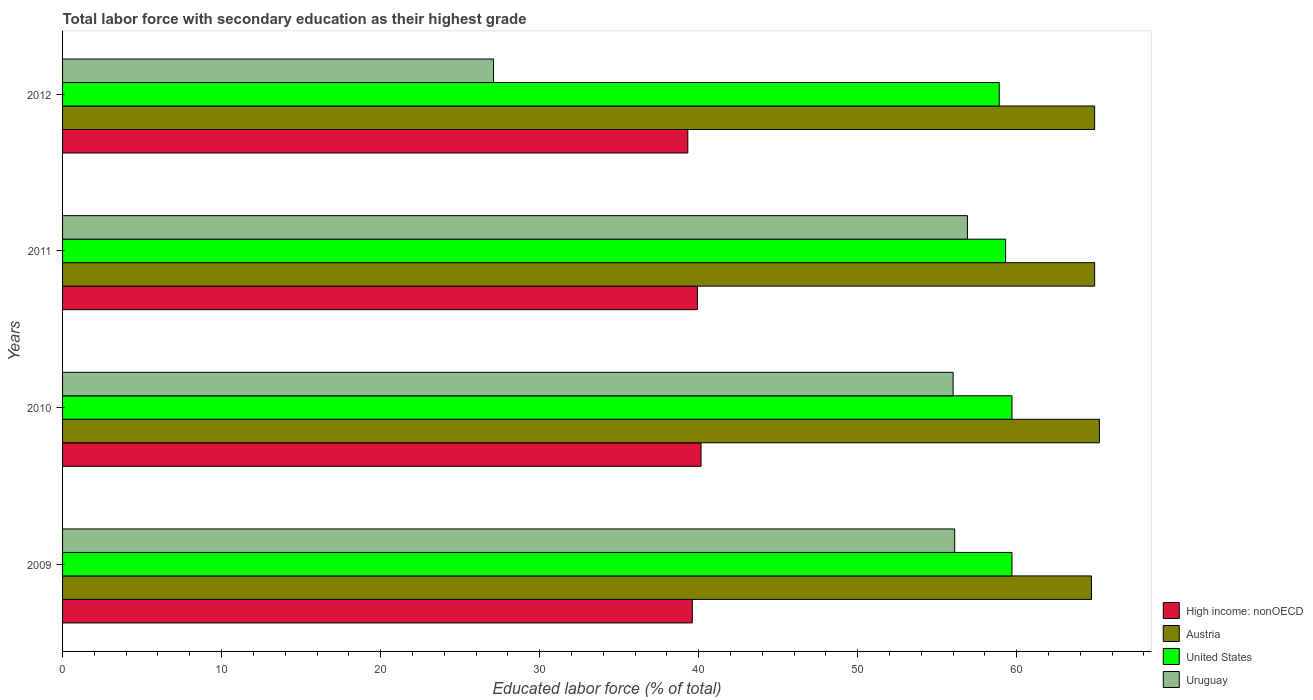How many bars are there on the 4th tick from the bottom?
Make the answer very short. 4. What is the percentage of total labor force with primary education in High income: nonOECD in 2010?
Give a very brief answer. 40.15. Across all years, what is the maximum percentage of total labor force with primary education in Uruguay?
Provide a short and direct response. 56.9. Across all years, what is the minimum percentage of total labor force with primary education in Uruguay?
Give a very brief answer. 27.1. In which year was the percentage of total labor force with primary education in High income: nonOECD minimum?
Offer a very short reply. 2012. What is the total percentage of total labor force with primary education in Austria in the graph?
Your answer should be compact. 259.7. What is the difference between the percentage of total labor force with primary education in Austria in 2011 and that in 2012?
Your response must be concise. 0. What is the difference between the percentage of total labor force with primary education in United States in 2009 and the percentage of total labor force with primary education in High income: nonOECD in 2011?
Make the answer very short. 19.78. What is the average percentage of total labor force with primary education in Uruguay per year?
Your response must be concise. 49.03. In the year 2011, what is the difference between the percentage of total labor force with primary education in Austria and percentage of total labor force with primary education in High income: nonOECD?
Provide a succinct answer. 24.98. What is the ratio of the percentage of total labor force with primary education in Austria in 2009 to that in 2012?
Provide a short and direct response. 1. Is the percentage of total labor force with primary education in Uruguay in 2010 less than that in 2012?
Make the answer very short. No. What is the difference between the highest and the lowest percentage of total labor force with primary education in High income: nonOECD?
Your answer should be very brief. 0.83. In how many years, is the percentage of total labor force with primary education in High income: nonOECD greater than the average percentage of total labor force with primary education in High income: nonOECD taken over all years?
Make the answer very short. 2. Is the sum of the percentage of total labor force with primary education in Uruguay in 2009 and 2011 greater than the maximum percentage of total labor force with primary education in High income: nonOECD across all years?
Your response must be concise. Yes. What does the 4th bar from the bottom in 2009 represents?
Provide a succinct answer. Uruguay. Is it the case that in every year, the sum of the percentage of total labor force with primary education in United States and percentage of total labor force with primary education in High income: nonOECD is greater than the percentage of total labor force with primary education in Austria?
Provide a short and direct response. Yes. Are all the bars in the graph horizontal?
Your answer should be compact. Yes. How many years are there in the graph?
Ensure brevity in your answer.  4. What is the difference between two consecutive major ticks on the X-axis?
Provide a succinct answer. 10. Are the values on the major ticks of X-axis written in scientific E-notation?
Ensure brevity in your answer.  No. Where does the legend appear in the graph?
Offer a very short reply. Bottom right. What is the title of the graph?
Offer a very short reply. Total labor force with secondary education as their highest grade. What is the label or title of the X-axis?
Provide a succinct answer. Educated labor force (% of total). What is the label or title of the Y-axis?
Provide a succinct answer. Years. What is the Educated labor force (% of total) of High income: nonOECD in 2009?
Your answer should be compact. 39.6. What is the Educated labor force (% of total) in Austria in 2009?
Keep it short and to the point. 64.7. What is the Educated labor force (% of total) of United States in 2009?
Your answer should be compact. 59.7. What is the Educated labor force (% of total) of Uruguay in 2009?
Offer a terse response. 56.1. What is the Educated labor force (% of total) of High income: nonOECD in 2010?
Offer a very short reply. 40.15. What is the Educated labor force (% of total) in Austria in 2010?
Offer a very short reply. 65.2. What is the Educated labor force (% of total) in United States in 2010?
Keep it short and to the point. 59.7. What is the Educated labor force (% of total) of High income: nonOECD in 2011?
Your response must be concise. 39.92. What is the Educated labor force (% of total) in Austria in 2011?
Offer a terse response. 64.9. What is the Educated labor force (% of total) of United States in 2011?
Offer a very short reply. 59.3. What is the Educated labor force (% of total) in Uruguay in 2011?
Your answer should be compact. 56.9. What is the Educated labor force (% of total) in High income: nonOECD in 2012?
Offer a terse response. 39.32. What is the Educated labor force (% of total) in Austria in 2012?
Keep it short and to the point. 64.9. What is the Educated labor force (% of total) in United States in 2012?
Provide a short and direct response. 58.9. What is the Educated labor force (% of total) of Uruguay in 2012?
Offer a terse response. 27.1. Across all years, what is the maximum Educated labor force (% of total) in High income: nonOECD?
Give a very brief answer. 40.15. Across all years, what is the maximum Educated labor force (% of total) in Austria?
Keep it short and to the point. 65.2. Across all years, what is the maximum Educated labor force (% of total) in United States?
Offer a very short reply. 59.7. Across all years, what is the maximum Educated labor force (% of total) of Uruguay?
Your response must be concise. 56.9. Across all years, what is the minimum Educated labor force (% of total) of High income: nonOECD?
Provide a succinct answer. 39.32. Across all years, what is the minimum Educated labor force (% of total) of Austria?
Your response must be concise. 64.7. Across all years, what is the minimum Educated labor force (% of total) in United States?
Offer a very short reply. 58.9. Across all years, what is the minimum Educated labor force (% of total) in Uruguay?
Ensure brevity in your answer.  27.1. What is the total Educated labor force (% of total) in High income: nonOECD in the graph?
Give a very brief answer. 158.99. What is the total Educated labor force (% of total) of Austria in the graph?
Your answer should be very brief. 259.7. What is the total Educated labor force (% of total) of United States in the graph?
Offer a very short reply. 237.6. What is the total Educated labor force (% of total) of Uruguay in the graph?
Provide a succinct answer. 196.1. What is the difference between the Educated labor force (% of total) in High income: nonOECD in 2009 and that in 2010?
Keep it short and to the point. -0.55. What is the difference between the Educated labor force (% of total) in United States in 2009 and that in 2010?
Make the answer very short. 0. What is the difference between the Educated labor force (% of total) in High income: nonOECD in 2009 and that in 2011?
Provide a short and direct response. -0.32. What is the difference between the Educated labor force (% of total) in Austria in 2009 and that in 2011?
Offer a very short reply. -0.2. What is the difference between the Educated labor force (% of total) in Uruguay in 2009 and that in 2011?
Give a very brief answer. -0.8. What is the difference between the Educated labor force (% of total) of High income: nonOECD in 2009 and that in 2012?
Your answer should be compact. 0.28. What is the difference between the Educated labor force (% of total) of United States in 2009 and that in 2012?
Keep it short and to the point. 0.8. What is the difference between the Educated labor force (% of total) in High income: nonOECD in 2010 and that in 2011?
Offer a very short reply. 0.23. What is the difference between the Educated labor force (% of total) of Austria in 2010 and that in 2011?
Make the answer very short. 0.3. What is the difference between the Educated labor force (% of total) of United States in 2010 and that in 2011?
Offer a very short reply. 0.4. What is the difference between the Educated labor force (% of total) of Uruguay in 2010 and that in 2011?
Provide a short and direct response. -0.9. What is the difference between the Educated labor force (% of total) in High income: nonOECD in 2010 and that in 2012?
Ensure brevity in your answer.  0.83. What is the difference between the Educated labor force (% of total) of Austria in 2010 and that in 2012?
Keep it short and to the point. 0.3. What is the difference between the Educated labor force (% of total) in United States in 2010 and that in 2012?
Provide a short and direct response. 0.8. What is the difference between the Educated labor force (% of total) of Uruguay in 2010 and that in 2012?
Provide a short and direct response. 28.9. What is the difference between the Educated labor force (% of total) in High income: nonOECD in 2011 and that in 2012?
Make the answer very short. 0.6. What is the difference between the Educated labor force (% of total) in Austria in 2011 and that in 2012?
Your answer should be compact. 0. What is the difference between the Educated labor force (% of total) in United States in 2011 and that in 2012?
Give a very brief answer. 0.4. What is the difference between the Educated labor force (% of total) in Uruguay in 2011 and that in 2012?
Provide a succinct answer. 29.8. What is the difference between the Educated labor force (% of total) in High income: nonOECD in 2009 and the Educated labor force (% of total) in Austria in 2010?
Ensure brevity in your answer.  -25.6. What is the difference between the Educated labor force (% of total) in High income: nonOECD in 2009 and the Educated labor force (% of total) in United States in 2010?
Offer a very short reply. -20.1. What is the difference between the Educated labor force (% of total) in High income: nonOECD in 2009 and the Educated labor force (% of total) in Uruguay in 2010?
Provide a short and direct response. -16.4. What is the difference between the Educated labor force (% of total) in United States in 2009 and the Educated labor force (% of total) in Uruguay in 2010?
Make the answer very short. 3.7. What is the difference between the Educated labor force (% of total) of High income: nonOECD in 2009 and the Educated labor force (% of total) of Austria in 2011?
Your response must be concise. -25.3. What is the difference between the Educated labor force (% of total) in High income: nonOECD in 2009 and the Educated labor force (% of total) in United States in 2011?
Offer a very short reply. -19.7. What is the difference between the Educated labor force (% of total) of High income: nonOECD in 2009 and the Educated labor force (% of total) of Uruguay in 2011?
Your answer should be compact. -17.3. What is the difference between the Educated labor force (% of total) of Austria in 2009 and the Educated labor force (% of total) of United States in 2011?
Make the answer very short. 5.4. What is the difference between the Educated labor force (% of total) of Austria in 2009 and the Educated labor force (% of total) of Uruguay in 2011?
Make the answer very short. 7.8. What is the difference between the Educated labor force (% of total) in High income: nonOECD in 2009 and the Educated labor force (% of total) in Austria in 2012?
Make the answer very short. -25.3. What is the difference between the Educated labor force (% of total) of High income: nonOECD in 2009 and the Educated labor force (% of total) of United States in 2012?
Your response must be concise. -19.3. What is the difference between the Educated labor force (% of total) of Austria in 2009 and the Educated labor force (% of total) of United States in 2012?
Your answer should be compact. 5.8. What is the difference between the Educated labor force (% of total) in Austria in 2009 and the Educated labor force (% of total) in Uruguay in 2012?
Your answer should be very brief. 37.6. What is the difference between the Educated labor force (% of total) in United States in 2009 and the Educated labor force (% of total) in Uruguay in 2012?
Your answer should be compact. 32.6. What is the difference between the Educated labor force (% of total) of High income: nonOECD in 2010 and the Educated labor force (% of total) of Austria in 2011?
Provide a short and direct response. -24.75. What is the difference between the Educated labor force (% of total) in High income: nonOECD in 2010 and the Educated labor force (% of total) in United States in 2011?
Offer a very short reply. -19.15. What is the difference between the Educated labor force (% of total) of High income: nonOECD in 2010 and the Educated labor force (% of total) of Uruguay in 2011?
Give a very brief answer. -16.75. What is the difference between the Educated labor force (% of total) of Austria in 2010 and the Educated labor force (% of total) of United States in 2011?
Provide a short and direct response. 5.9. What is the difference between the Educated labor force (% of total) in United States in 2010 and the Educated labor force (% of total) in Uruguay in 2011?
Make the answer very short. 2.8. What is the difference between the Educated labor force (% of total) of High income: nonOECD in 2010 and the Educated labor force (% of total) of Austria in 2012?
Your answer should be very brief. -24.75. What is the difference between the Educated labor force (% of total) in High income: nonOECD in 2010 and the Educated labor force (% of total) in United States in 2012?
Provide a succinct answer. -18.75. What is the difference between the Educated labor force (% of total) in High income: nonOECD in 2010 and the Educated labor force (% of total) in Uruguay in 2012?
Give a very brief answer. 13.05. What is the difference between the Educated labor force (% of total) in Austria in 2010 and the Educated labor force (% of total) in Uruguay in 2012?
Provide a short and direct response. 38.1. What is the difference between the Educated labor force (% of total) of United States in 2010 and the Educated labor force (% of total) of Uruguay in 2012?
Offer a terse response. 32.6. What is the difference between the Educated labor force (% of total) of High income: nonOECD in 2011 and the Educated labor force (% of total) of Austria in 2012?
Your answer should be very brief. -24.98. What is the difference between the Educated labor force (% of total) in High income: nonOECD in 2011 and the Educated labor force (% of total) in United States in 2012?
Your response must be concise. -18.98. What is the difference between the Educated labor force (% of total) of High income: nonOECD in 2011 and the Educated labor force (% of total) of Uruguay in 2012?
Keep it short and to the point. 12.82. What is the difference between the Educated labor force (% of total) of Austria in 2011 and the Educated labor force (% of total) of United States in 2012?
Your answer should be compact. 6. What is the difference between the Educated labor force (% of total) of Austria in 2011 and the Educated labor force (% of total) of Uruguay in 2012?
Your response must be concise. 37.8. What is the difference between the Educated labor force (% of total) of United States in 2011 and the Educated labor force (% of total) of Uruguay in 2012?
Make the answer very short. 32.2. What is the average Educated labor force (% of total) in High income: nonOECD per year?
Keep it short and to the point. 39.75. What is the average Educated labor force (% of total) of Austria per year?
Provide a succinct answer. 64.92. What is the average Educated labor force (% of total) of United States per year?
Your answer should be very brief. 59.4. What is the average Educated labor force (% of total) in Uruguay per year?
Give a very brief answer. 49.02. In the year 2009, what is the difference between the Educated labor force (% of total) in High income: nonOECD and Educated labor force (% of total) in Austria?
Your answer should be compact. -25.1. In the year 2009, what is the difference between the Educated labor force (% of total) of High income: nonOECD and Educated labor force (% of total) of United States?
Your answer should be very brief. -20.1. In the year 2009, what is the difference between the Educated labor force (% of total) in High income: nonOECD and Educated labor force (% of total) in Uruguay?
Give a very brief answer. -16.5. In the year 2009, what is the difference between the Educated labor force (% of total) in Austria and Educated labor force (% of total) in Uruguay?
Keep it short and to the point. 8.6. In the year 2010, what is the difference between the Educated labor force (% of total) in High income: nonOECD and Educated labor force (% of total) in Austria?
Your answer should be compact. -25.05. In the year 2010, what is the difference between the Educated labor force (% of total) in High income: nonOECD and Educated labor force (% of total) in United States?
Ensure brevity in your answer.  -19.55. In the year 2010, what is the difference between the Educated labor force (% of total) in High income: nonOECD and Educated labor force (% of total) in Uruguay?
Give a very brief answer. -15.85. In the year 2010, what is the difference between the Educated labor force (% of total) of Austria and Educated labor force (% of total) of Uruguay?
Your response must be concise. 9.2. In the year 2010, what is the difference between the Educated labor force (% of total) of United States and Educated labor force (% of total) of Uruguay?
Provide a short and direct response. 3.7. In the year 2011, what is the difference between the Educated labor force (% of total) in High income: nonOECD and Educated labor force (% of total) in Austria?
Ensure brevity in your answer.  -24.98. In the year 2011, what is the difference between the Educated labor force (% of total) of High income: nonOECD and Educated labor force (% of total) of United States?
Offer a terse response. -19.38. In the year 2011, what is the difference between the Educated labor force (% of total) in High income: nonOECD and Educated labor force (% of total) in Uruguay?
Offer a terse response. -16.98. In the year 2011, what is the difference between the Educated labor force (% of total) in Austria and Educated labor force (% of total) in United States?
Provide a succinct answer. 5.6. In the year 2011, what is the difference between the Educated labor force (% of total) of Austria and Educated labor force (% of total) of Uruguay?
Make the answer very short. 8. In the year 2011, what is the difference between the Educated labor force (% of total) in United States and Educated labor force (% of total) in Uruguay?
Your answer should be compact. 2.4. In the year 2012, what is the difference between the Educated labor force (% of total) of High income: nonOECD and Educated labor force (% of total) of Austria?
Provide a short and direct response. -25.58. In the year 2012, what is the difference between the Educated labor force (% of total) in High income: nonOECD and Educated labor force (% of total) in United States?
Give a very brief answer. -19.58. In the year 2012, what is the difference between the Educated labor force (% of total) of High income: nonOECD and Educated labor force (% of total) of Uruguay?
Your answer should be very brief. 12.22. In the year 2012, what is the difference between the Educated labor force (% of total) of Austria and Educated labor force (% of total) of Uruguay?
Offer a very short reply. 37.8. In the year 2012, what is the difference between the Educated labor force (% of total) in United States and Educated labor force (% of total) in Uruguay?
Your answer should be compact. 31.8. What is the ratio of the Educated labor force (% of total) in High income: nonOECD in 2009 to that in 2010?
Make the answer very short. 0.99. What is the ratio of the Educated labor force (% of total) in United States in 2009 to that in 2010?
Offer a terse response. 1. What is the ratio of the Educated labor force (% of total) in Uruguay in 2009 to that in 2010?
Your response must be concise. 1. What is the ratio of the Educated labor force (% of total) of Austria in 2009 to that in 2011?
Offer a very short reply. 1. What is the ratio of the Educated labor force (% of total) in United States in 2009 to that in 2011?
Keep it short and to the point. 1.01. What is the ratio of the Educated labor force (% of total) in Uruguay in 2009 to that in 2011?
Offer a very short reply. 0.99. What is the ratio of the Educated labor force (% of total) in United States in 2009 to that in 2012?
Provide a succinct answer. 1.01. What is the ratio of the Educated labor force (% of total) in Uruguay in 2009 to that in 2012?
Make the answer very short. 2.07. What is the ratio of the Educated labor force (% of total) in High income: nonOECD in 2010 to that in 2011?
Your answer should be very brief. 1.01. What is the ratio of the Educated labor force (% of total) in United States in 2010 to that in 2011?
Provide a succinct answer. 1.01. What is the ratio of the Educated labor force (% of total) of Uruguay in 2010 to that in 2011?
Offer a terse response. 0.98. What is the ratio of the Educated labor force (% of total) in High income: nonOECD in 2010 to that in 2012?
Give a very brief answer. 1.02. What is the ratio of the Educated labor force (% of total) in Austria in 2010 to that in 2012?
Keep it short and to the point. 1. What is the ratio of the Educated labor force (% of total) of United States in 2010 to that in 2012?
Give a very brief answer. 1.01. What is the ratio of the Educated labor force (% of total) in Uruguay in 2010 to that in 2012?
Make the answer very short. 2.07. What is the ratio of the Educated labor force (% of total) of High income: nonOECD in 2011 to that in 2012?
Give a very brief answer. 1.02. What is the ratio of the Educated labor force (% of total) of Austria in 2011 to that in 2012?
Keep it short and to the point. 1. What is the ratio of the Educated labor force (% of total) in United States in 2011 to that in 2012?
Offer a very short reply. 1.01. What is the ratio of the Educated labor force (% of total) in Uruguay in 2011 to that in 2012?
Make the answer very short. 2.1. What is the difference between the highest and the second highest Educated labor force (% of total) of High income: nonOECD?
Your response must be concise. 0.23. What is the difference between the highest and the lowest Educated labor force (% of total) in High income: nonOECD?
Offer a terse response. 0.83. What is the difference between the highest and the lowest Educated labor force (% of total) of Austria?
Provide a short and direct response. 0.5. What is the difference between the highest and the lowest Educated labor force (% of total) in United States?
Keep it short and to the point. 0.8. What is the difference between the highest and the lowest Educated labor force (% of total) in Uruguay?
Your answer should be compact. 29.8. 